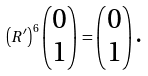Convert formula to latex. <formula><loc_0><loc_0><loc_500><loc_500>\left ( R ^ { \prime } \right ) ^ { 6 } \begin{pmatrix} 0 \\ 1 \end{pmatrix} = \begin{pmatrix} 0 \\ 1 \end{pmatrix} \text {.}</formula> 